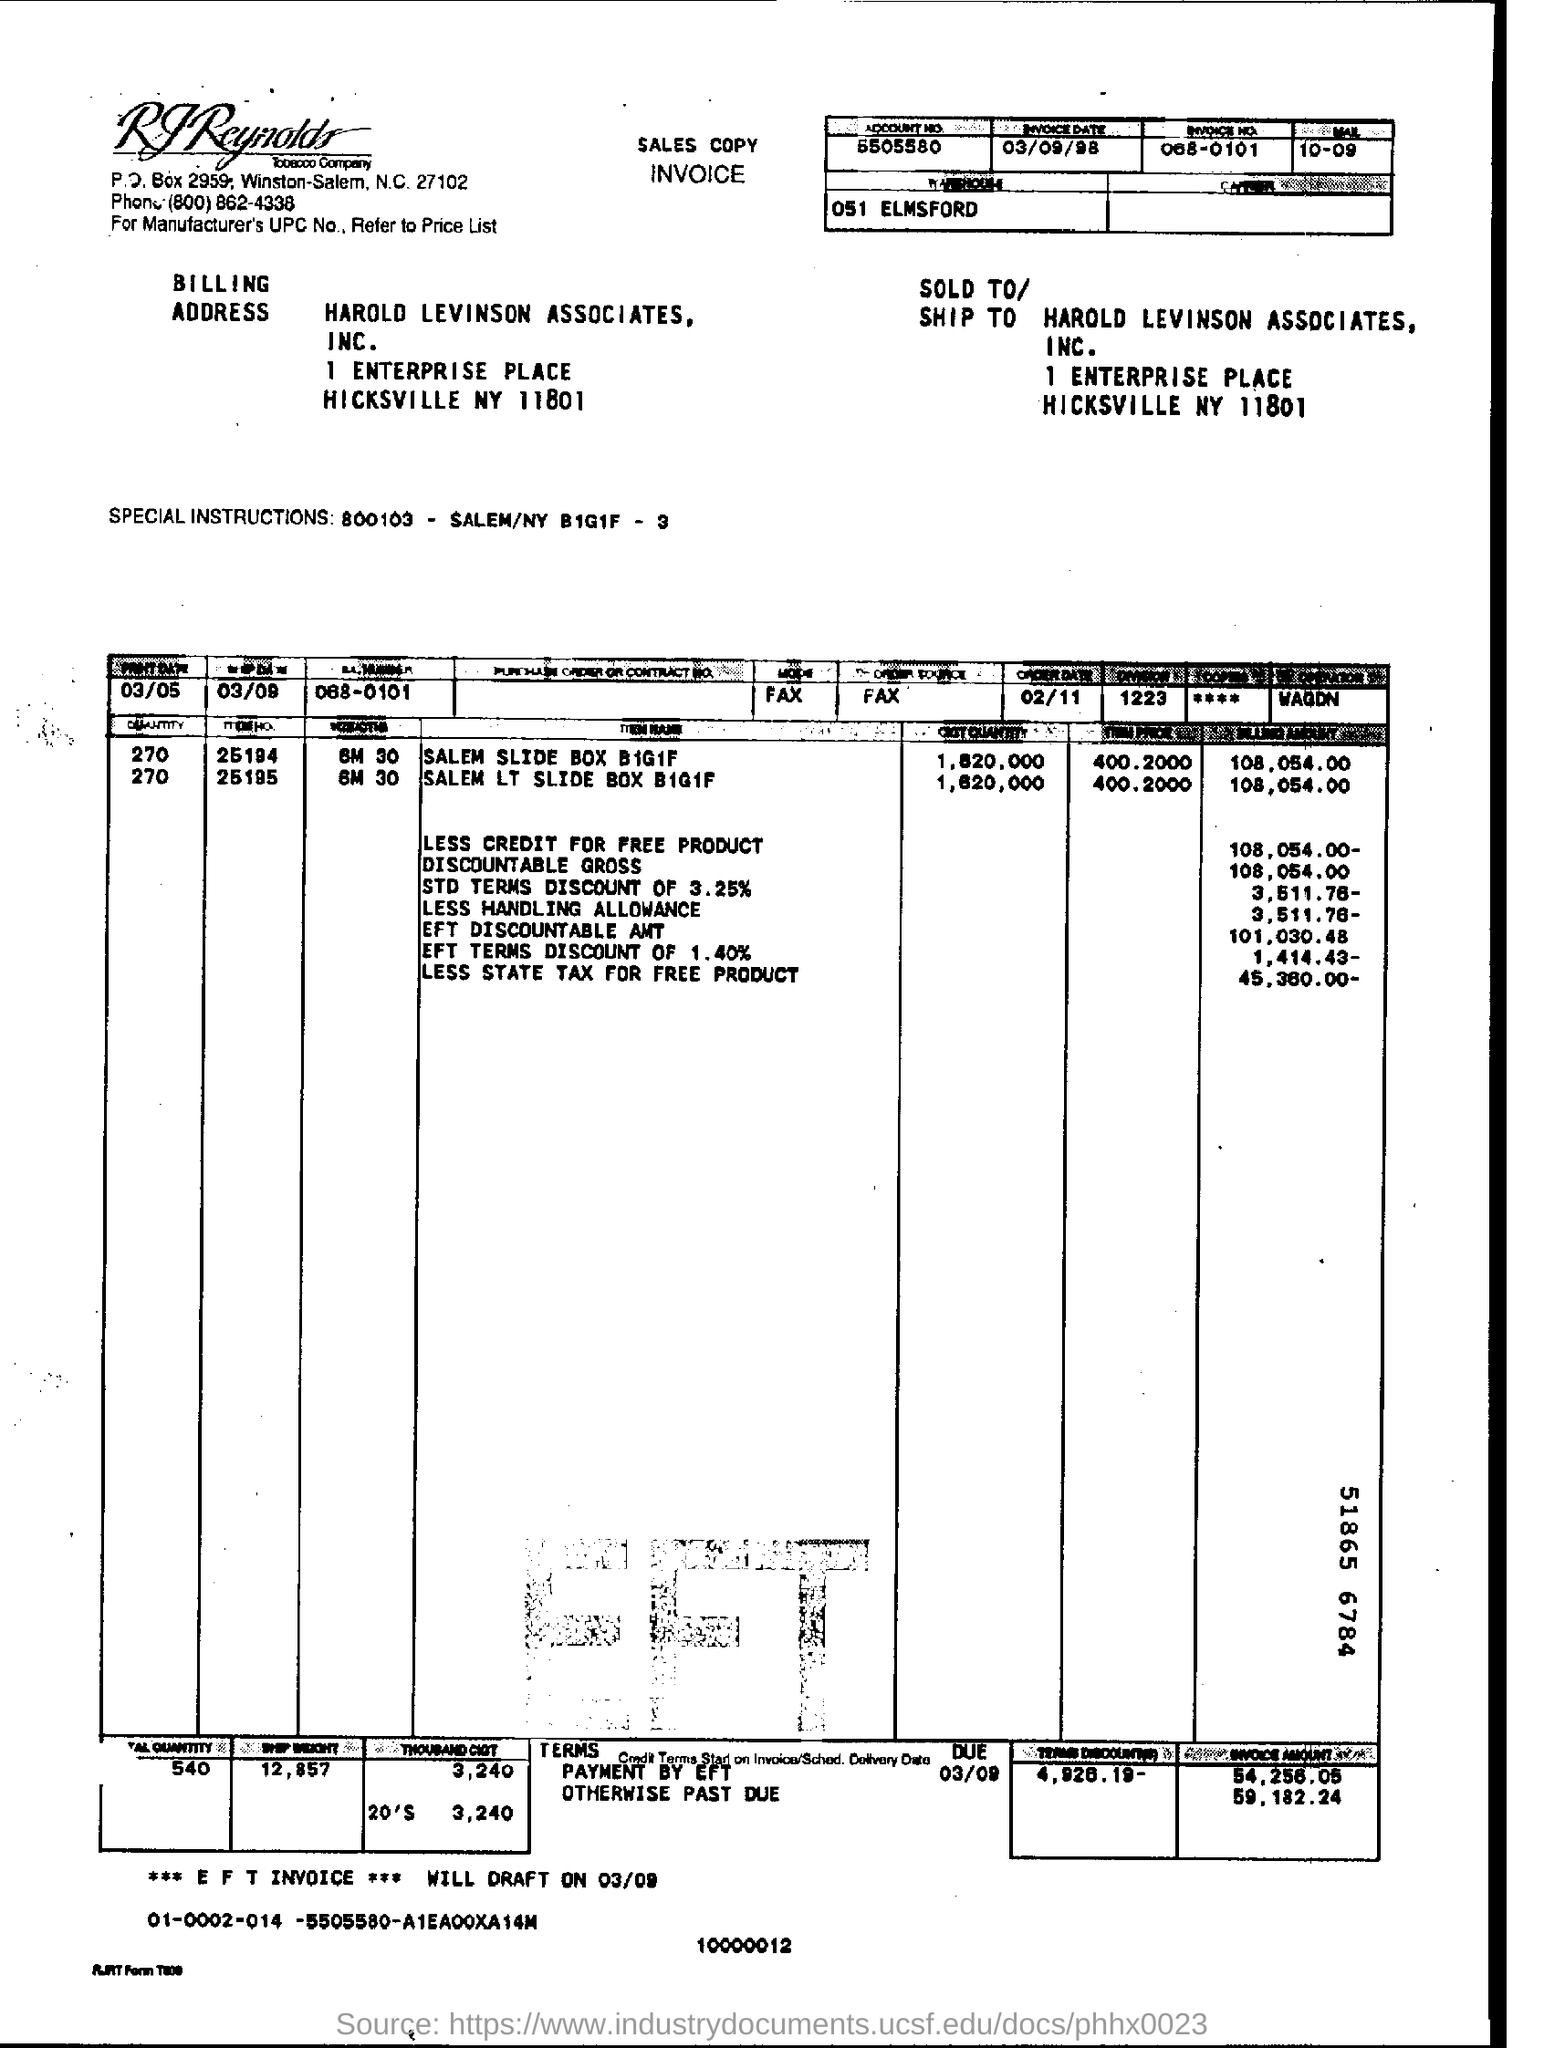Give some essential details in this illustration. The invoice date is September 3, 1998. 